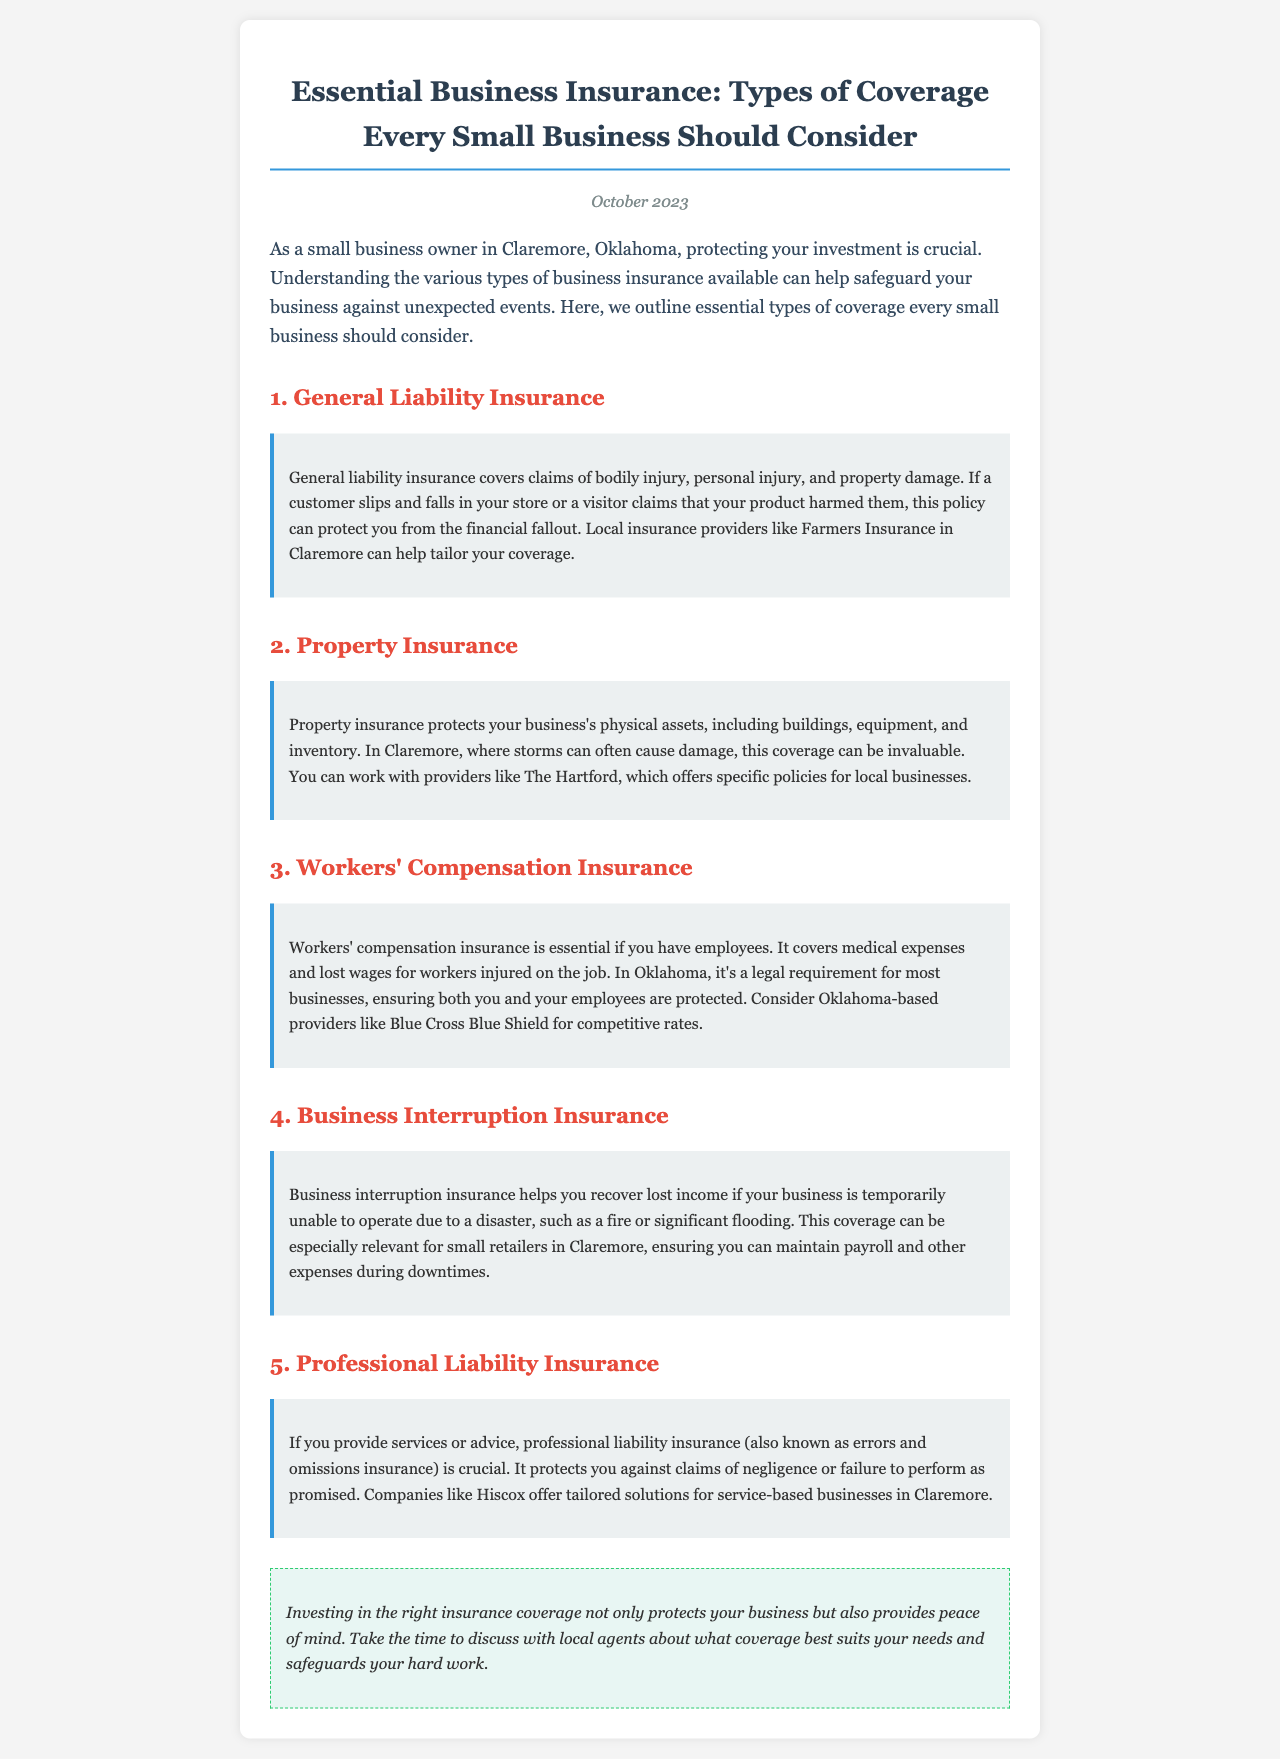what is the title of the newsletter? The title of the newsletter is provided in the heading at the top of the document.
Answer: Essential Business Insurance: Types of Coverage Every Small Business Should Consider what is the date of publication? The publication date is mentioned prominently in the newsletter.
Answer: October 2023 which insurance covers bodily injury claims? The newsletter specifies different types of insurance, and one section details the coverage provided for bodily injury claims.
Answer: General Liability Insurance what type of insurance is legally required for most businesses in Oklahoma? The document states that a specific type of insurance is legally required if a business has employees in Oklahoma.
Answer: Workers' Compensation Insurance who is a recommended insurance provider for business property coverage? The document highlights a specific provider that offers property insurance tailored for local businesses.
Answer: The Hartford what does business interruption insurance help recover? A section of the newsletter explains the purpose of business interruption insurance, specifically what it helps businesses recover.
Answer: Lost income which insurance protects against claims of negligence? The newsletter describes the role of a particular type of insurance related to service and advice provision.
Answer: Professional Liability Insurance what is the primary focus of this newsletter? The overall focus and intent of the newsletter is described in the introductory paragraph.
Answer: Business insurance coverage who is mentioned as a local insurance provider in Claremore? The document notes specific insurance providers that cater to businesses in Claremore.
Answer: Farmers Insurance 